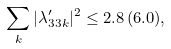Convert formula to latex. <formula><loc_0><loc_0><loc_500><loc_500>\sum _ { k } | \lambda _ { 3 3 k } ^ { \prime } | ^ { 2 } \leq 2 . 8 \, ( 6 . 0 ) ,</formula> 